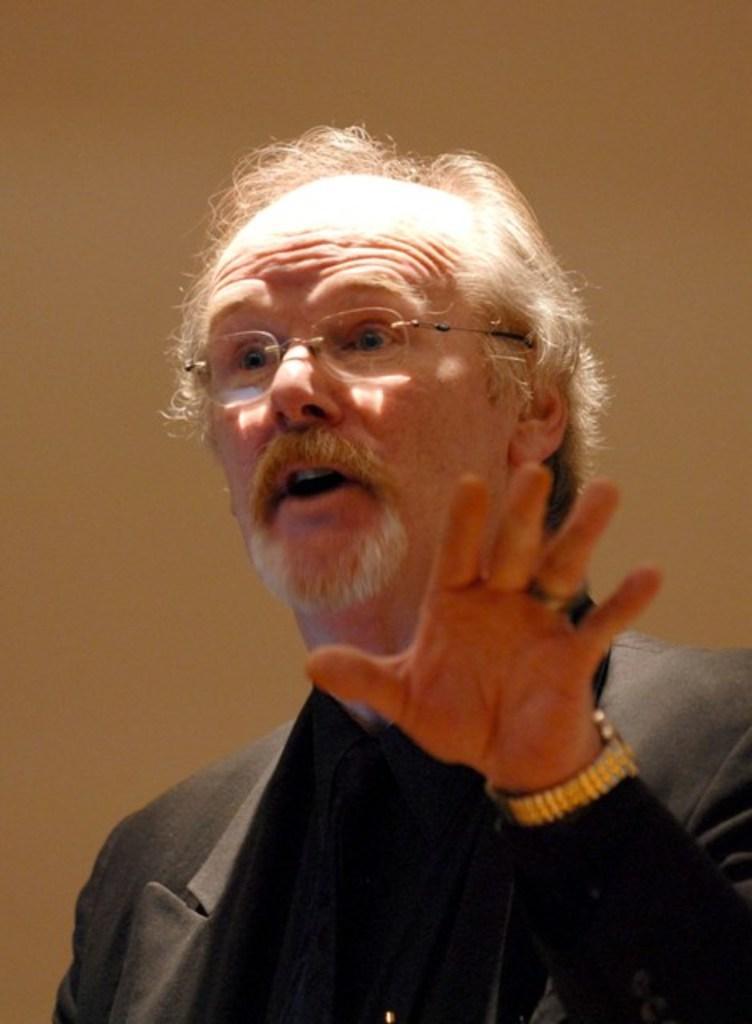Could you give a brief overview of what you see in this image? In this image we can see an old person wearing spectacles and a suit is talking. 